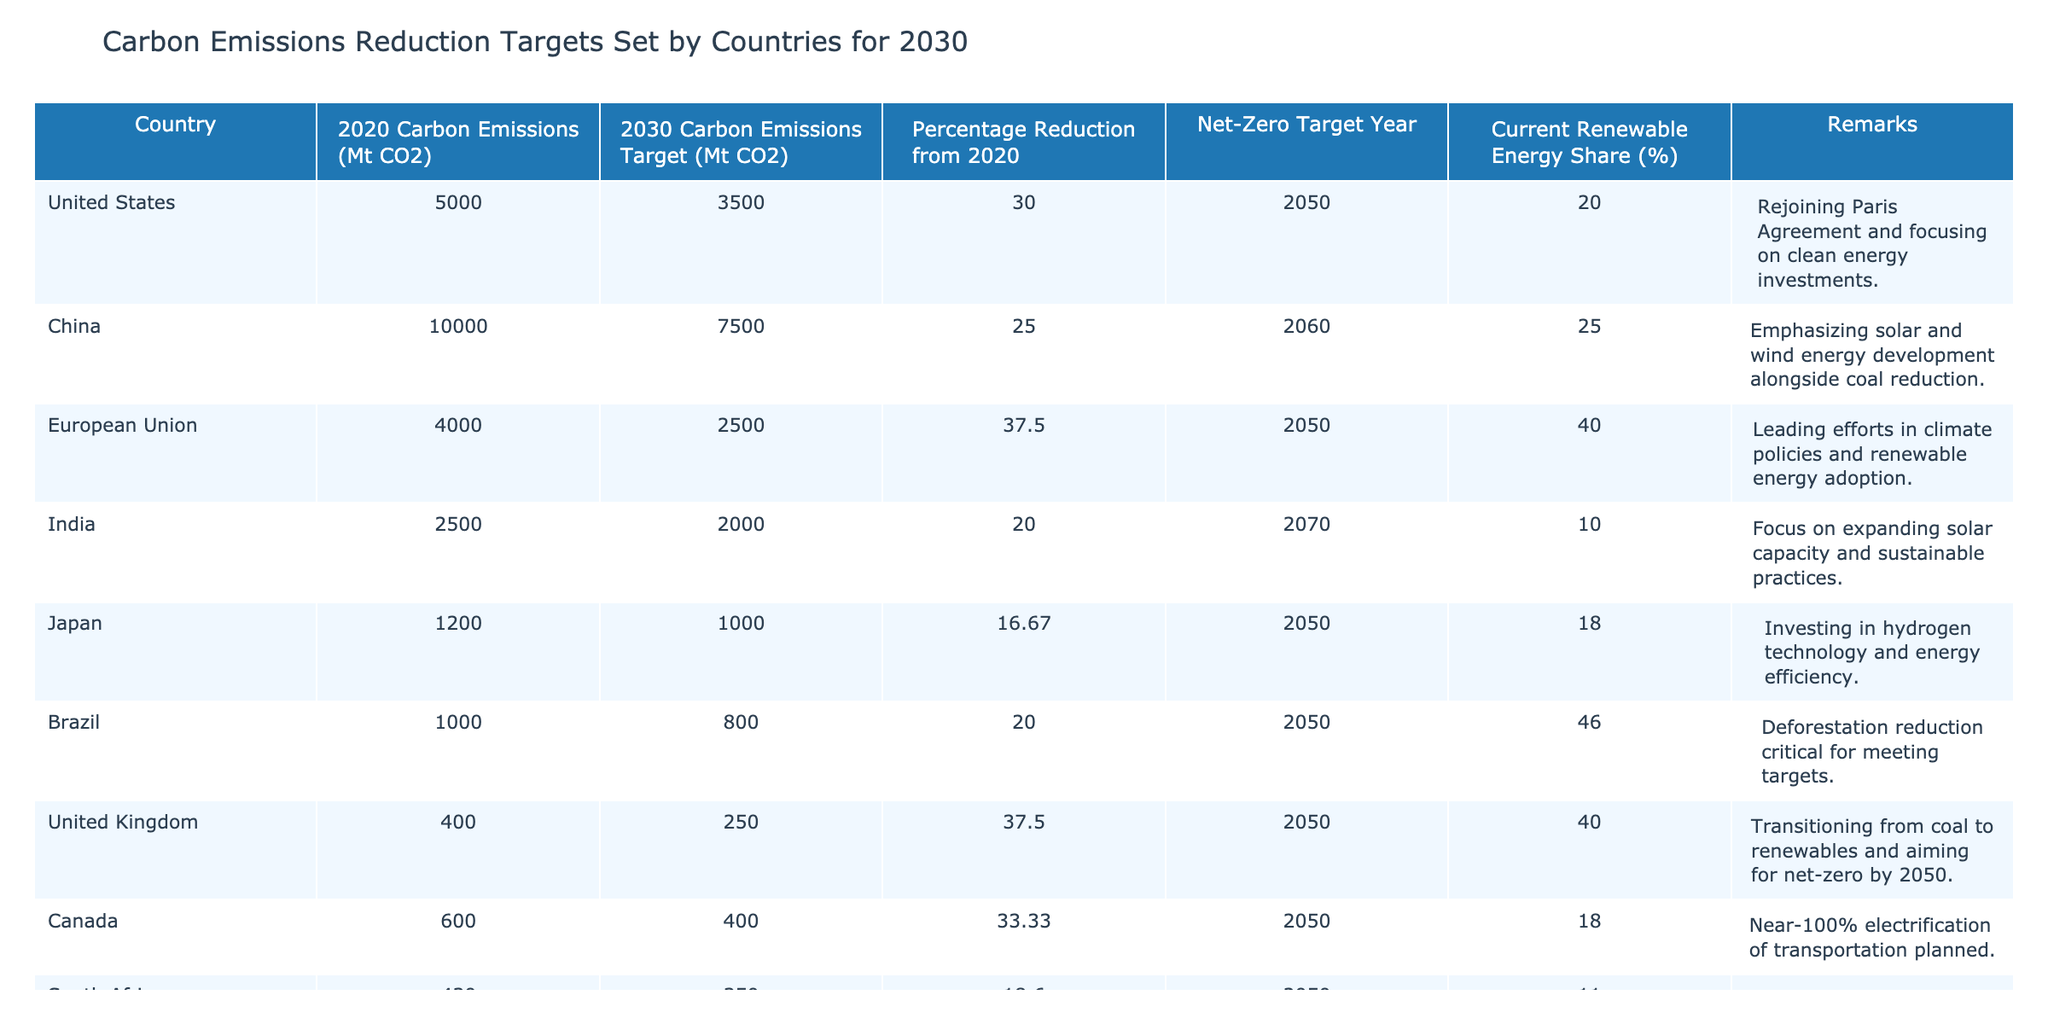What is the 2030 carbon emissions target for the European Union? The table indicates that the 2030 carbon emissions target for the European Union is 2500 Mt CO2.
Answer: 2500 Mt CO2 Which country has the highest percentage reduction target from 2020? Upon examining the data, the European Union has the highest percentage reduction target from 2020, which is 37.5%.
Answer: European Union Is Brazil's current renewable energy share greater than 40%? The table shows that Brazil's current renewable energy share is 46%, which is greater than 40%.
Answer: Yes What is the average percentage reduction target of the countries listed? To find the average percentage reduction target, first sum the targets: (30 + 25 + 37.5 + 20 + 16.67 + 20 + 37.5 + 33.33 + 18.60 + 16.67) =  304.27. Then, divide by the number of countries (10): 304.27/10 = 30.43.
Answer: 30.43 Which country has the earliest net-zero target year? Checking the net-zero target years, India aims for 2070, while the countries with earlier targets are the United States, China, the European Union, Japan, Brazil, the United Kingdom, Canada, South Africa, and Australia, all targeting 2050. Therefore, the earliest year is 2050 for multiple countries.
Answer: 2050 What is the difference between the current carbon emissions of Canada and South Africa? The current carbon emissions for Canada are 600 Mt CO2, while for South Africa, it is 430 Mt CO2. Calculating the difference gives: 600 - 430 = 170.
Answer: 170 Mt CO2 Does India have a net-zero target year later than 2050? The table specifies that India has a net-zero target year of 2070, which is indeed later than 2050.
Answer: Yes Which country has the lowest carbon emissions target for 2030? Among the countries listed, Japan has the lowest carbon emissions target for 2030 at 1000 Mt CO2.
Answer: Japan 